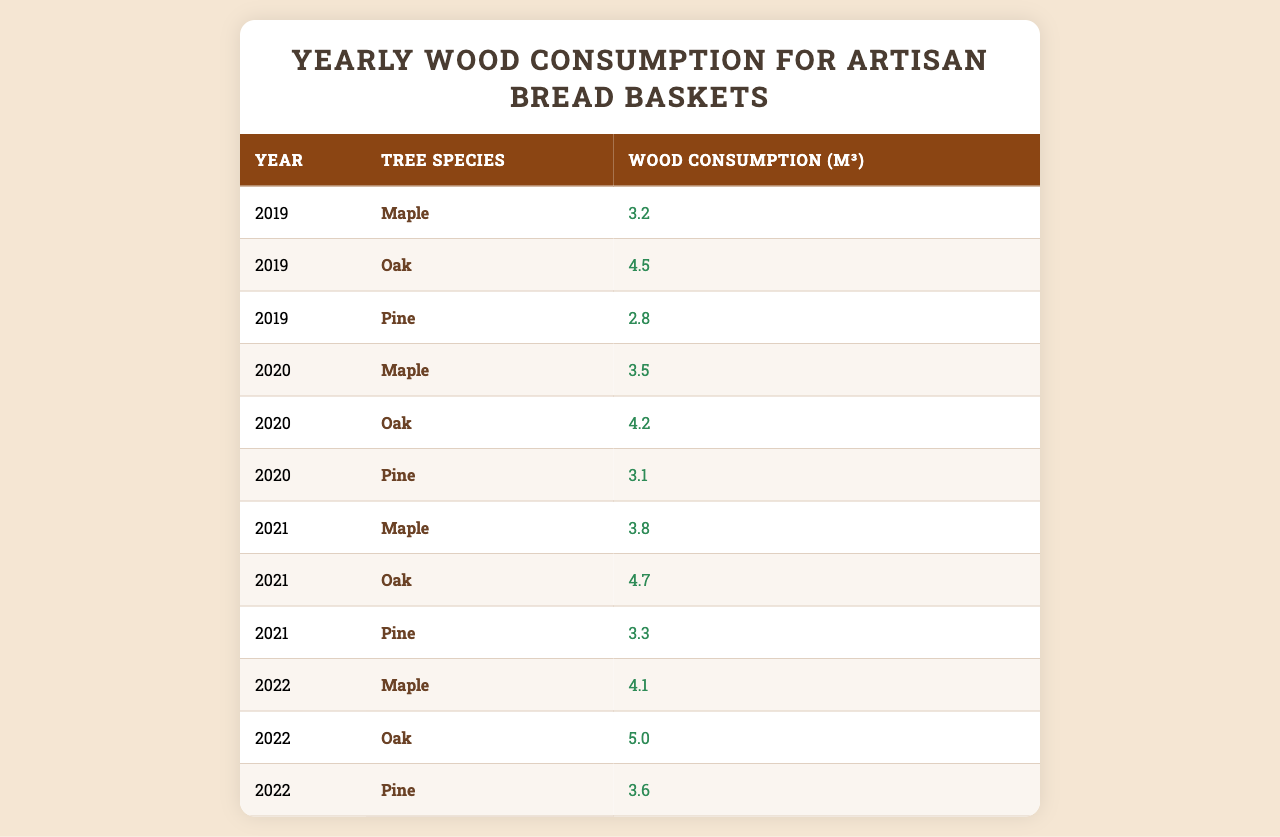What is the wood consumption for Maple in 2021? The table lists Maple's wood consumption for 2021 as 3.8 cubic meters.
Answer: 3.8 Which tree species had the highest wood consumption in 2022? In 2022, Oak had the highest wood consumption with 5.0 cubic meters, compared to Maple and Pine.
Answer: Oak How much wood was consumed for Pine in 2020 compared to 2021? In 2020, Pine consumed 3.1 cubic meters, while in 2021 it consumed 3.3 cubic meters. The difference is 3.3 - 3.1 = 0.2 cubic meters more in 2021.
Answer: 0.2 more What is the average wood consumption for each tree species across all years? For Maple: (3.2 + 3.5 + 3.8 + 4.1) / 4 = 3.65; for Oak: (4.5 + 4.2 + 4.7 + 5.0) / 4 = 4.6; for Pine: (2.8 + 3.1 + 3.3 + 3.6) / 4 = 3.2.
Answer: Maple: 3.65, Oak: 4.6, Pine: 3.2 Was the total wood consumption higher for Oak or Pine across all years? Total for Oak is 4.5 + 4.2 + 4.7 + 5.0 = 18.4 cubic meters, and for Pine it is 2.8 + 3.1 + 3.3 + 3.6 = 12.8 cubic meters. Therefore, Oak consumed more wood.
Answer: Oak What year had the lowest total wood consumption across all tree species? The yearly totals: 2019: 3.2 + 4.5 + 2.8 = 10.5; 2020: 3.5 + 4.2 + 3.1 = 10.8; 2021: 3.8 + 4.7 + 3.3 = 11.8; 2022: 4.1 + 5.0 + 3.6 = 12.7. The lowest is 2019 with 10.5 cubic meters.
Answer: 2019 How many cubic meters of wood were consumed in total from 2019 to 2022? The total wood consumption is 10.5 (2019) + 10.8 (2020) + 11.8 (2021) + 12.7 (2022) = 46.8 cubic meters.
Answer: 46.8 Which species showed the most significant increase in consumption from 2019 to 2022? The increase for Maple is 4.1 - 3.2 = 0.9; for Oak: 5.0 - 4.5 = 0.5; for Pine: 3.6 - 2.8 = 0.8. Maple had the highest increase of 0.9 cubic meters.
Answer: Maple 